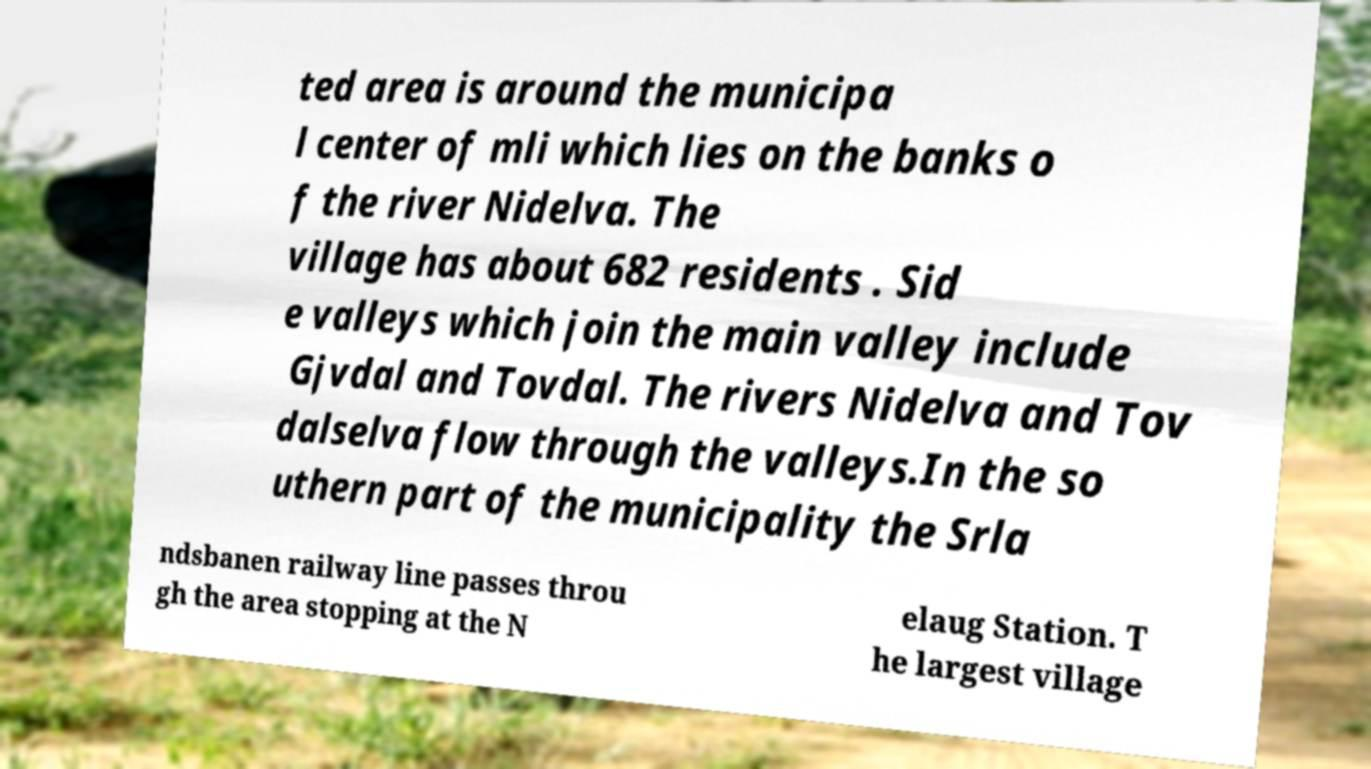Please identify and transcribe the text found in this image. ted area is around the municipa l center of mli which lies on the banks o f the river Nidelva. The village has about 682 residents . Sid e valleys which join the main valley include Gjvdal and Tovdal. The rivers Nidelva and Tov dalselva flow through the valleys.In the so uthern part of the municipality the Srla ndsbanen railway line passes throu gh the area stopping at the N elaug Station. T he largest village 